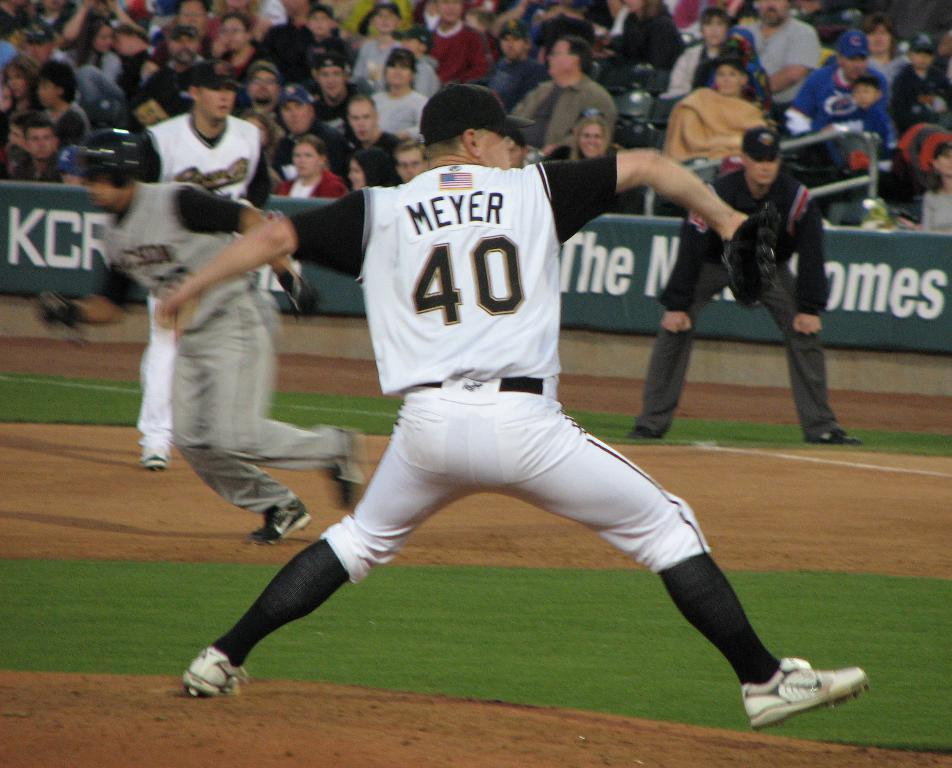<image>
Write a terse but informative summary of the picture. A baseball player who is throwing a ball wearing a jersey reading Meyer 40 